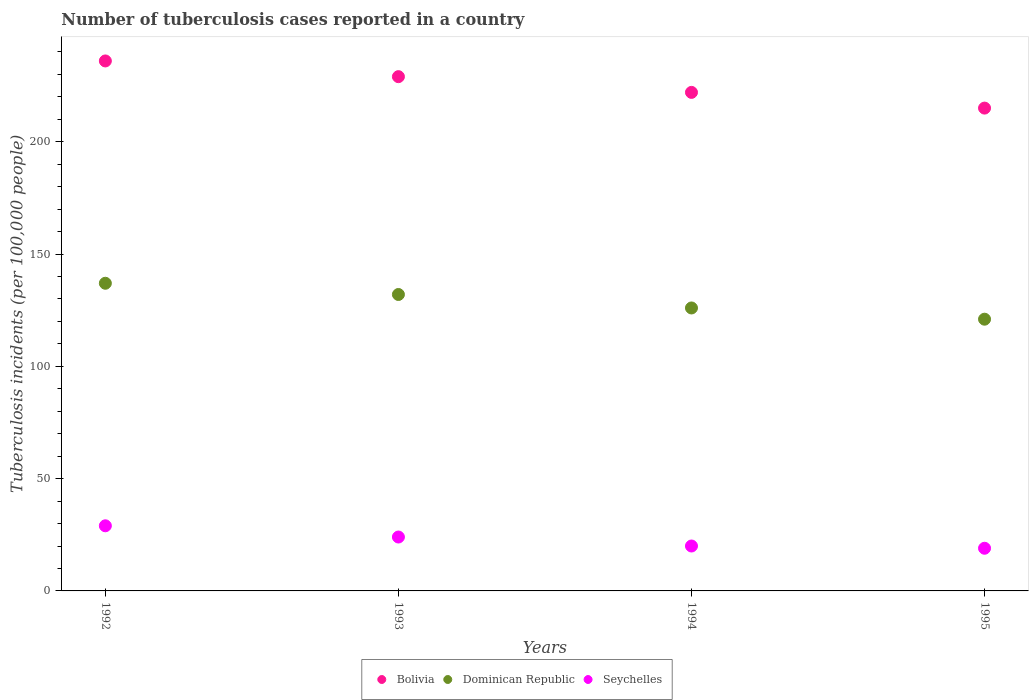How many different coloured dotlines are there?
Your answer should be very brief. 3. Is the number of dotlines equal to the number of legend labels?
Offer a terse response. Yes. What is the number of tuberculosis cases reported in in Dominican Republic in 1995?
Provide a short and direct response. 121. Across all years, what is the maximum number of tuberculosis cases reported in in Dominican Republic?
Provide a short and direct response. 137. Across all years, what is the minimum number of tuberculosis cases reported in in Bolivia?
Offer a very short reply. 215. In which year was the number of tuberculosis cases reported in in Seychelles maximum?
Offer a very short reply. 1992. In which year was the number of tuberculosis cases reported in in Seychelles minimum?
Your answer should be very brief. 1995. What is the total number of tuberculosis cases reported in in Dominican Republic in the graph?
Offer a very short reply. 516. What is the difference between the number of tuberculosis cases reported in in Bolivia in 1994 and that in 1995?
Give a very brief answer. 7. What is the difference between the number of tuberculosis cases reported in in Seychelles in 1992 and the number of tuberculosis cases reported in in Dominican Republic in 1995?
Ensure brevity in your answer.  -92. What is the average number of tuberculosis cases reported in in Dominican Republic per year?
Provide a succinct answer. 129. In the year 1992, what is the difference between the number of tuberculosis cases reported in in Bolivia and number of tuberculosis cases reported in in Seychelles?
Ensure brevity in your answer.  207. What is the ratio of the number of tuberculosis cases reported in in Seychelles in 1992 to that in 1993?
Your answer should be compact. 1.21. Is the number of tuberculosis cases reported in in Dominican Republic in 1992 less than that in 1993?
Ensure brevity in your answer.  No. Is the difference between the number of tuberculosis cases reported in in Bolivia in 1992 and 1993 greater than the difference between the number of tuberculosis cases reported in in Seychelles in 1992 and 1993?
Provide a short and direct response. Yes. What is the difference between the highest and the second highest number of tuberculosis cases reported in in Seychelles?
Your response must be concise. 5. What is the difference between the highest and the lowest number of tuberculosis cases reported in in Dominican Republic?
Your answer should be very brief. 16. Is the sum of the number of tuberculosis cases reported in in Dominican Republic in 1993 and 1994 greater than the maximum number of tuberculosis cases reported in in Seychelles across all years?
Give a very brief answer. Yes. Does the number of tuberculosis cases reported in in Seychelles monotonically increase over the years?
Provide a short and direct response. No. Is the number of tuberculosis cases reported in in Seychelles strictly less than the number of tuberculosis cases reported in in Dominican Republic over the years?
Offer a very short reply. Yes. How many years are there in the graph?
Provide a succinct answer. 4. Does the graph contain any zero values?
Your response must be concise. No. Does the graph contain grids?
Offer a terse response. No. How many legend labels are there?
Your response must be concise. 3. What is the title of the graph?
Provide a short and direct response. Number of tuberculosis cases reported in a country. Does "Fiji" appear as one of the legend labels in the graph?
Ensure brevity in your answer.  No. What is the label or title of the X-axis?
Provide a succinct answer. Years. What is the label or title of the Y-axis?
Your answer should be very brief. Tuberculosis incidents (per 100,0 people). What is the Tuberculosis incidents (per 100,000 people) in Bolivia in 1992?
Your answer should be compact. 236. What is the Tuberculosis incidents (per 100,000 people) in Dominican Republic in 1992?
Offer a very short reply. 137. What is the Tuberculosis incidents (per 100,000 people) of Bolivia in 1993?
Your answer should be compact. 229. What is the Tuberculosis incidents (per 100,000 people) of Dominican Republic in 1993?
Your answer should be compact. 132. What is the Tuberculosis incidents (per 100,000 people) in Bolivia in 1994?
Offer a terse response. 222. What is the Tuberculosis incidents (per 100,000 people) in Dominican Republic in 1994?
Provide a succinct answer. 126. What is the Tuberculosis incidents (per 100,000 people) in Seychelles in 1994?
Give a very brief answer. 20. What is the Tuberculosis incidents (per 100,000 people) in Bolivia in 1995?
Your answer should be very brief. 215. What is the Tuberculosis incidents (per 100,000 people) in Dominican Republic in 1995?
Your answer should be compact. 121. What is the Tuberculosis incidents (per 100,000 people) in Seychelles in 1995?
Offer a terse response. 19. Across all years, what is the maximum Tuberculosis incidents (per 100,000 people) in Bolivia?
Make the answer very short. 236. Across all years, what is the maximum Tuberculosis incidents (per 100,000 people) of Dominican Republic?
Provide a short and direct response. 137. Across all years, what is the maximum Tuberculosis incidents (per 100,000 people) of Seychelles?
Your answer should be compact. 29. Across all years, what is the minimum Tuberculosis incidents (per 100,000 people) in Bolivia?
Provide a short and direct response. 215. Across all years, what is the minimum Tuberculosis incidents (per 100,000 people) of Dominican Republic?
Your answer should be compact. 121. What is the total Tuberculosis incidents (per 100,000 people) in Bolivia in the graph?
Keep it short and to the point. 902. What is the total Tuberculosis incidents (per 100,000 people) in Dominican Republic in the graph?
Keep it short and to the point. 516. What is the total Tuberculosis incidents (per 100,000 people) of Seychelles in the graph?
Offer a very short reply. 92. What is the difference between the Tuberculosis incidents (per 100,000 people) in Bolivia in 1992 and that in 1993?
Make the answer very short. 7. What is the difference between the Tuberculosis incidents (per 100,000 people) in Dominican Republic in 1992 and that in 1993?
Give a very brief answer. 5. What is the difference between the Tuberculosis incidents (per 100,000 people) in Dominican Republic in 1992 and that in 1994?
Make the answer very short. 11. What is the difference between the Tuberculosis incidents (per 100,000 people) in Bolivia in 1992 and that in 1995?
Make the answer very short. 21. What is the difference between the Tuberculosis incidents (per 100,000 people) of Dominican Republic in 1993 and that in 1994?
Provide a short and direct response. 6. What is the difference between the Tuberculosis incidents (per 100,000 people) in Seychelles in 1993 and that in 1994?
Your answer should be very brief. 4. What is the difference between the Tuberculosis incidents (per 100,000 people) in Seychelles in 1993 and that in 1995?
Offer a very short reply. 5. What is the difference between the Tuberculosis incidents (per 100,000 people) of Dominican Republic in 1994 and that in 1995?
Your response must be concise. 5. What is the difference between the Tuberculosis incidents (per 100,000 people) in Bolivia in 1992 and the Tuberculosis incidents (per 100,000 people) in Dominican Republic in 1993?
Provide a short and direct response. 104. What is the difference between the Tuberculosis incidents (per 100,000 people) in Bolivia in 1992 and the Tuberculosis incidents (per 100,000 people) in Seychelles in 1993?
Provide a short and direct response. 212. What is the difference between the Tuberculosis incidents (per 100,000 people) in Dominican Republic in 1992 and the Tuberculosis incidents (per 100,000 people) in Seychelles in 1993?
Keep it short and to the point. 113. What is the difference between the Tuberculosis incidents (per 100,000 people) of Bolivia in 1992 and the Tuberculosis incidents (per 100,000 people) of Dominican Republic in 1994?
Your answer should be very brief. 110. What is the difference between the Tuberculosis incidents (per 100,000 people) in Bolivia in 1992 and the Tuberculosis incidents (per 100,000 people) in Seychelles in 1994?
Give a very brief answer. 216. What is the difference between the Tuberculosis incidents (per 100,000 people) in Dominican Republic in 1992 and the Tuberculosis incidents (per 100,000 people) in Seychelles in 1994?
Your answer should be very brief. 117. What is the difference between the Tuberculosis incidents (per 100,000 people) of Bolivia in 1992 and the Tuberculosis incidents (per 100,000 people) of Dominican Republic in 1995?
Your answer should be compact. 115. What is the difference between the Tuberculosis incidents (per 100,000 people) in Bolivia in 1992 and the Tuberculosis incidents (per 100,000 people) in Seychelles in 1995?
Provide a short and direct response. 217. What is the difference between the Tuberculosis incidents (per 100,000 people) of Dominican Republic in 1992 and the Tuberculosis incidents (per 100,000 people) of Seychelles in 1995?
Your response must be concise. 118. What is the difference between the Tuberculosis incidents (per 100,000 people) of Bolivia in 1993 and the Tuberculosis incidents (per 100,000 people) of Dominican Republic in 1994?
Your response must be concise. 103. What is the difference between the Tuberculosis incidents (per 100,000 people) in Bolivia in 1993 and the Tuberculosis incidents (per 100,000 people) in Seychelles in 1994?
Offer a very short reply. 209. What is the difference between the Tuberculosis incidents (per 100,000 people) of Dominican Republic in 1993 and the Tuberculosis incidents (per 100,000 people) of Seychelles in 1994?
Keep it short and to the point. 112. What is the difference between the Tuberculosis incidents (per 100,000 people) in Bolivia in 1993 and the Tuberculosis incidents (per 100,000 people) in Dominican Republic in 1995?
Your response must be concise. 108. What is the difference between the Tuberculosis incidents (per 100,000 people) of Bolivia in 1993 and the Tuberculosis incidents (per 100,000 people) of Seychelles in 1995?
Provide a short and direct response. 210. What is the difference between the Tuberculosis incidents (per 100,000 people) of Dominican Republic in 1993 and the Tuberculosis incidents (per 100,000 people) of Seychelles in 1995?
Keep it short and to the point. 113. What is the difference between the Tuberculosis incidents (per 100,000 people) of Bolivia in 1994 and the Tuberculosis incidents (per 100,000 people) of Dominican Republic in 1995?
Make the answer very short. 101. What is the difference between the Tuberculosis incidents (per 100,000 people) in Bolivia in 1994 and the Tuberculosis incidents (per 100,000 people) in Seychelles in 1995?
Provide a succinct answer. 203. What is the difference between the Tuberculosis incidents (per 100,000 people) in Dominican Republic in 1994 and the Tuberculosis incidents (per 100,000 people) in Seychelles in 1995?
Provide a succinct answer. 107. What is the average Tuberculosis incidents (per 100,000 people) in Bolivia per year?
Your answer should be compact. 225.5. What is the average Tuberculosis incidents (per 100,000 people) in Dominican Republic per year?
Ensure brevity in your answer.  129. In the year 1992, what is the difference between the Tuberculosis incidents (per 100,000 people) of Bolivia and Tuberculosis incidents (per 100,000 people) of Seychelles?
Your response must be concise. 207. In the year 1992, what is the difference between the Tuberculosis incidents (per 100,000 people) in Dominican Republic and Tuberculosis incidents (per 100,000 people) in Seychelles?
Give a very brief answer. 108. In the year 1993, what is the difference between the Tuberculosis incidents (per 100,000 people) of Bolivia and Tuberculosis incidents (per 100,000 people) of Dominican Republic?
Offer a terse response. 97. In the year 1993, what is the difference between the Tuberculosis incidents (per 100,000 people) of Bolivia and Tuberculosis incidents (per 100,000 people) of Seychelles?
Keep it short and to the point. 205. In the year 1993, what is the difference between the Tuberculosis incidents (per 100,000 people) in Dominican Republic and Tuberculosis incidents (per 100,000 people) in Seychelles?
Provide a succinct answer. 108. In the year 1994, what is the difference between the Tuberculosis incidents (per 100,000 people) of Bolivia and Tuberculosis incidents (per 100,000 people) of Dominican Republic?
Ensure brevity in your answer.  96. In the year 1994, what is the difference between the Tuberculosis incidents (per 100,000 people) of Bolivia and Tuberculosis incidents (per 100,000 people) of Seychelles?
Your answer should be very brief. 202. In the year 1994, what is the difference between the Tuberculosis incidents (per 100,000 people) of Dominican Republic and Tuberculosis incidents (per 100,000 people) of Seychelles?
Give a very brief answer. 106. In the year 1995, what is the difference between the Tuberculosis incidents (per 100,000 people) of Bolivia and Tuberculosis incidents (per 100,000 people) of Dominican Republic?
Provide a short and direct response. 94. In the year 1995, what is the difference between the Tuberculosis incidents (per 100,000 people) of Bolivia and Tuberculosis incidents (per 100,000 people) of Seychelles?
Provide a succinct answer. 196. In the year 1995, what is the difference between the Tuberculosis incidents (per 100,000 people) in Dominican Republic and Tuberculosis incidents (per 100,000 people) in Seychelles?
Provide a short and direct response. 102. What is the ratio of the Tuberculosis incidents (per 100,000 people) in Bolivia in 1992 to that in 1993?
Offer a very short reply. 1.03. What is the ratio of the Tuberculosis incidents (per 100,000 people) of Dominican Republic in 1992 to that in 1993?
Your answer should be compact. 1.04. What is the ratio of the Tuberculosis incidents (per 100,000 people) in Seychelles in 1992 to that in 1993?
Offer a terse response. 1.21. What is the ratio of the Tuberculosis incidents (per 100,000 people) of Bolivia in 1992 to that in 1994?
Provide a short and direct response. 1.06. What is the ratio of the Tuberculosis incidents (per 100,000 people) of Dominican Republic in 1992 to that in 1994?
Your answer should be very brief. 1.09. What is the ratio of the Tuberculosis incidents (per 100,000 people) in Seychelles in 1992 to that in 1994?
Give a very brief answer. 1.45. What is the ratio of the Tuberculosis incidents (per 100,000 people) in Bolivia in 1992 to that in 1995?
Your answer should be compact. 1.1. What is the ratio of the Tuberculosis incidents (per 100,000 people) in Dominican Republic in 1992 to that in 1995?
Provide a short and direct response. 1.13. What is the ratio of the Tuberculosis incidents (per 100,000 people) in Seychelles in 1992 to that in 1995?
Your response must be concise. 1.53. What is the ratio of the Tuberculosis incidents (per 100,000 people) of Bolivia in 1993 to that in 1994?
Give a very brief answer. 1.03. What is the ratio of the Tuberculosis incidents (per 100,000 people) of Dominican Republic in 1993 to that in 1994?
Offer a terse response. 1.05. What is the ratio of the Tuberculosis incidents (per 100,000 people) of Seychelles in 1993 to that in 1994?
Ensure brevity in your answer.  1.2. What is the ratio of the Tuberculosis incidents (per 100,000 people) in Bolivia in 1993 to that in 1995?
Provide a succinct answer. 1.07. What is the ratio of the Tuberculosis incidents (per 100,000 people) of Dominican Republic in 1993 to that in 1995?
Make the answer very short. 1.09. What is the ratio of the Tuberculosis incidents (per 100,000 people) of Seychelles in 1993 to that in 1995?
Your answer should be very brief. 1.26. What is the ratio of the Tuberculosis incidents (per 100,000 people) in Bolivia in 1994 to that in 1995?
Offer a terse response. 1.03. What is the ratio of the Tuberculosis incidents (per 100,000 people) in Dominican Republic in 1994 to that in 1995?
Your response must be concise. 1.04. What is the ratio of the Tuberculosis incidents (per 100,000 people) of Seychelles in 1994 to that in 1995?
Make the answer very short. 1.05. What is the difference between the highest and the second highest Tuberculosis incidents (per 100,000 people) in Dominican Republic?
Give a very brief answer. 5. What is the difference between the highest and the second highest Tuberculosis incidents (per 100,000 people) in Seychelles?
Provide a short and direct response. 5. What is the difference between the highest and the lowest Tuberculosis incidents (per 100,000 people) in Bolivia?
Ensure brevity in your answer.  21. What is the difference between the highest and the lowest Tuberculosis incidents (per 100,000 people) in Dominican Republic?
Provide a short and direct response. 16. 